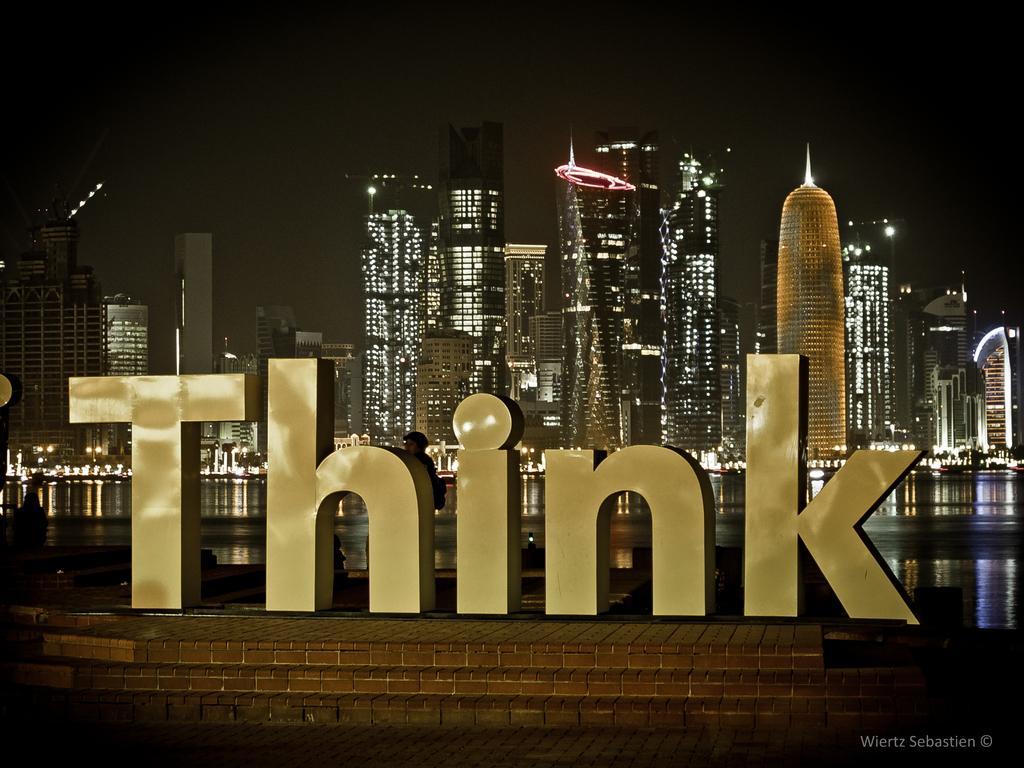Can you describe this image briefly? In the image there are alphabet emblems in the foreground and behind the emblems there is a water surface and behind the water surface there are buildings. 